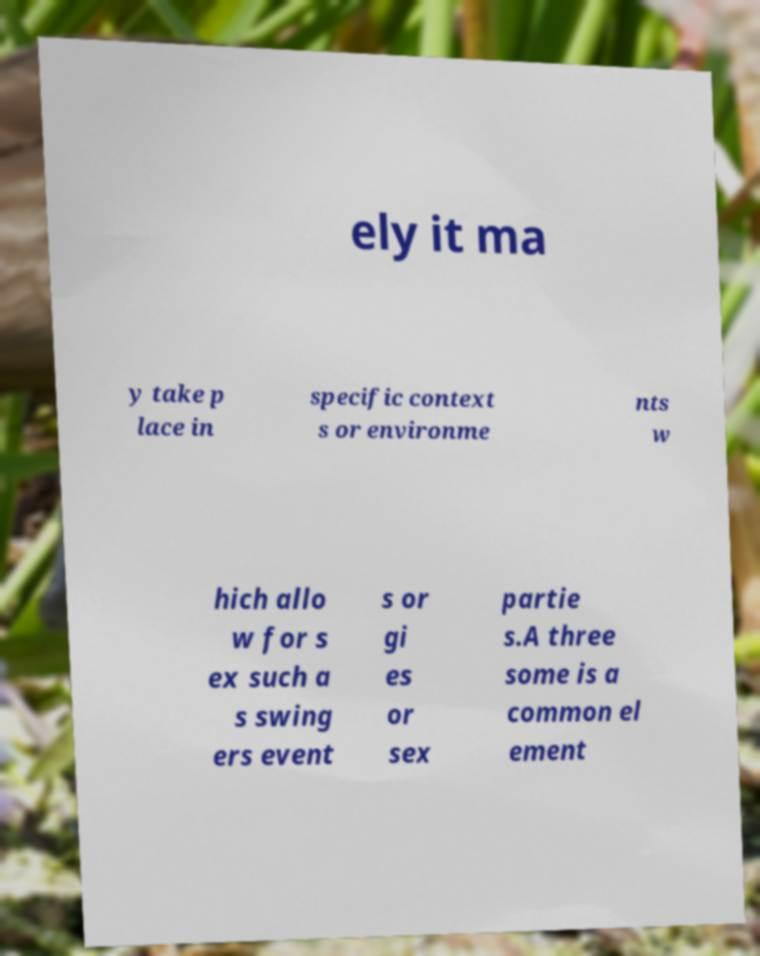There's text embedded in this image that I need extracted. Can you transcribe it verbatim? ely it ma y take p lace in specific context s or environme nts w hich allo w for s ex such a s swing ers event s or gi es or sex partie s.A three some is a common el ement 